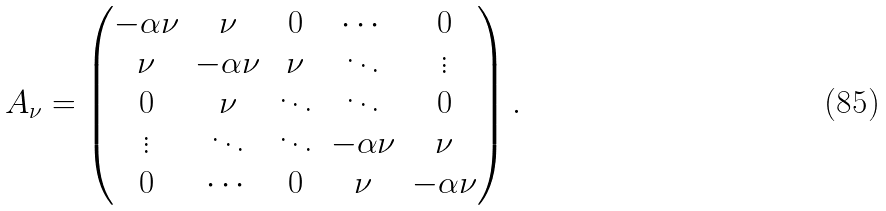<formula> <loc_0><loc_0><loc_500><loc_500>A _ { \nu } = \begin{pmatrix} - \alpha \nu & \nu & 0 & \cdots & 0 \\ \nu & - \alpha \nu & \nu & \ddots & \vdots \\ 0 & \nu & \ddots & \ddots & 0 \\ \vdots & \ddots & \ddots & - \alpha \nu & \nu \\ 0 & \cdots & 0 & \nu & - \alpha \nu \end{pmatrix} .</formula> 